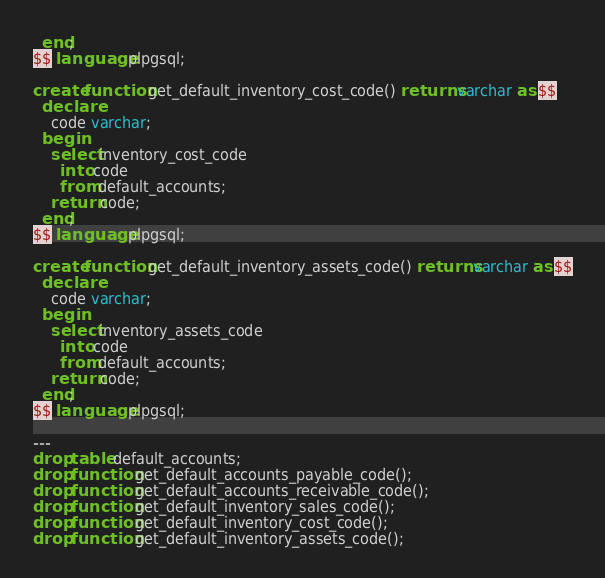<code> <loc_0><loc_0><loc_500><loc_500><_SQL_>  end;
$$ language plpgsql;

create function get_default_inventory_cost_code() returns varchar as $$
  declare
    code varchar;
  begin
    select inventory_cost_code
      into code
      from default_accounts;
    return code;
  end;
$$ language plpgsql;

create function get_default_inventory_assets_code() returns varchar as $$
  declare
    code varchar;
  begin
    select inventory_assets_code
      into code
      from default_accounts;
    return code;
  end;
$$ language plpgsql;

---
drop table default_accounts;
drop function get_default_accounts_payable_code();
drop function get_default_accounts_receivable_code();
drop function get_default_inventory_sales_code();
drop function get_default_inventory_cost_code();
drop function get_default_inventory_assets_code();
</code> 